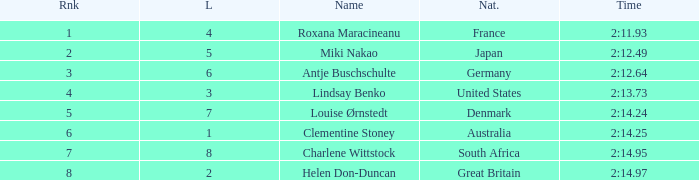What shows for nationality when there is a rank larger than 6, and a Time of 2:14.95? South Africa. 